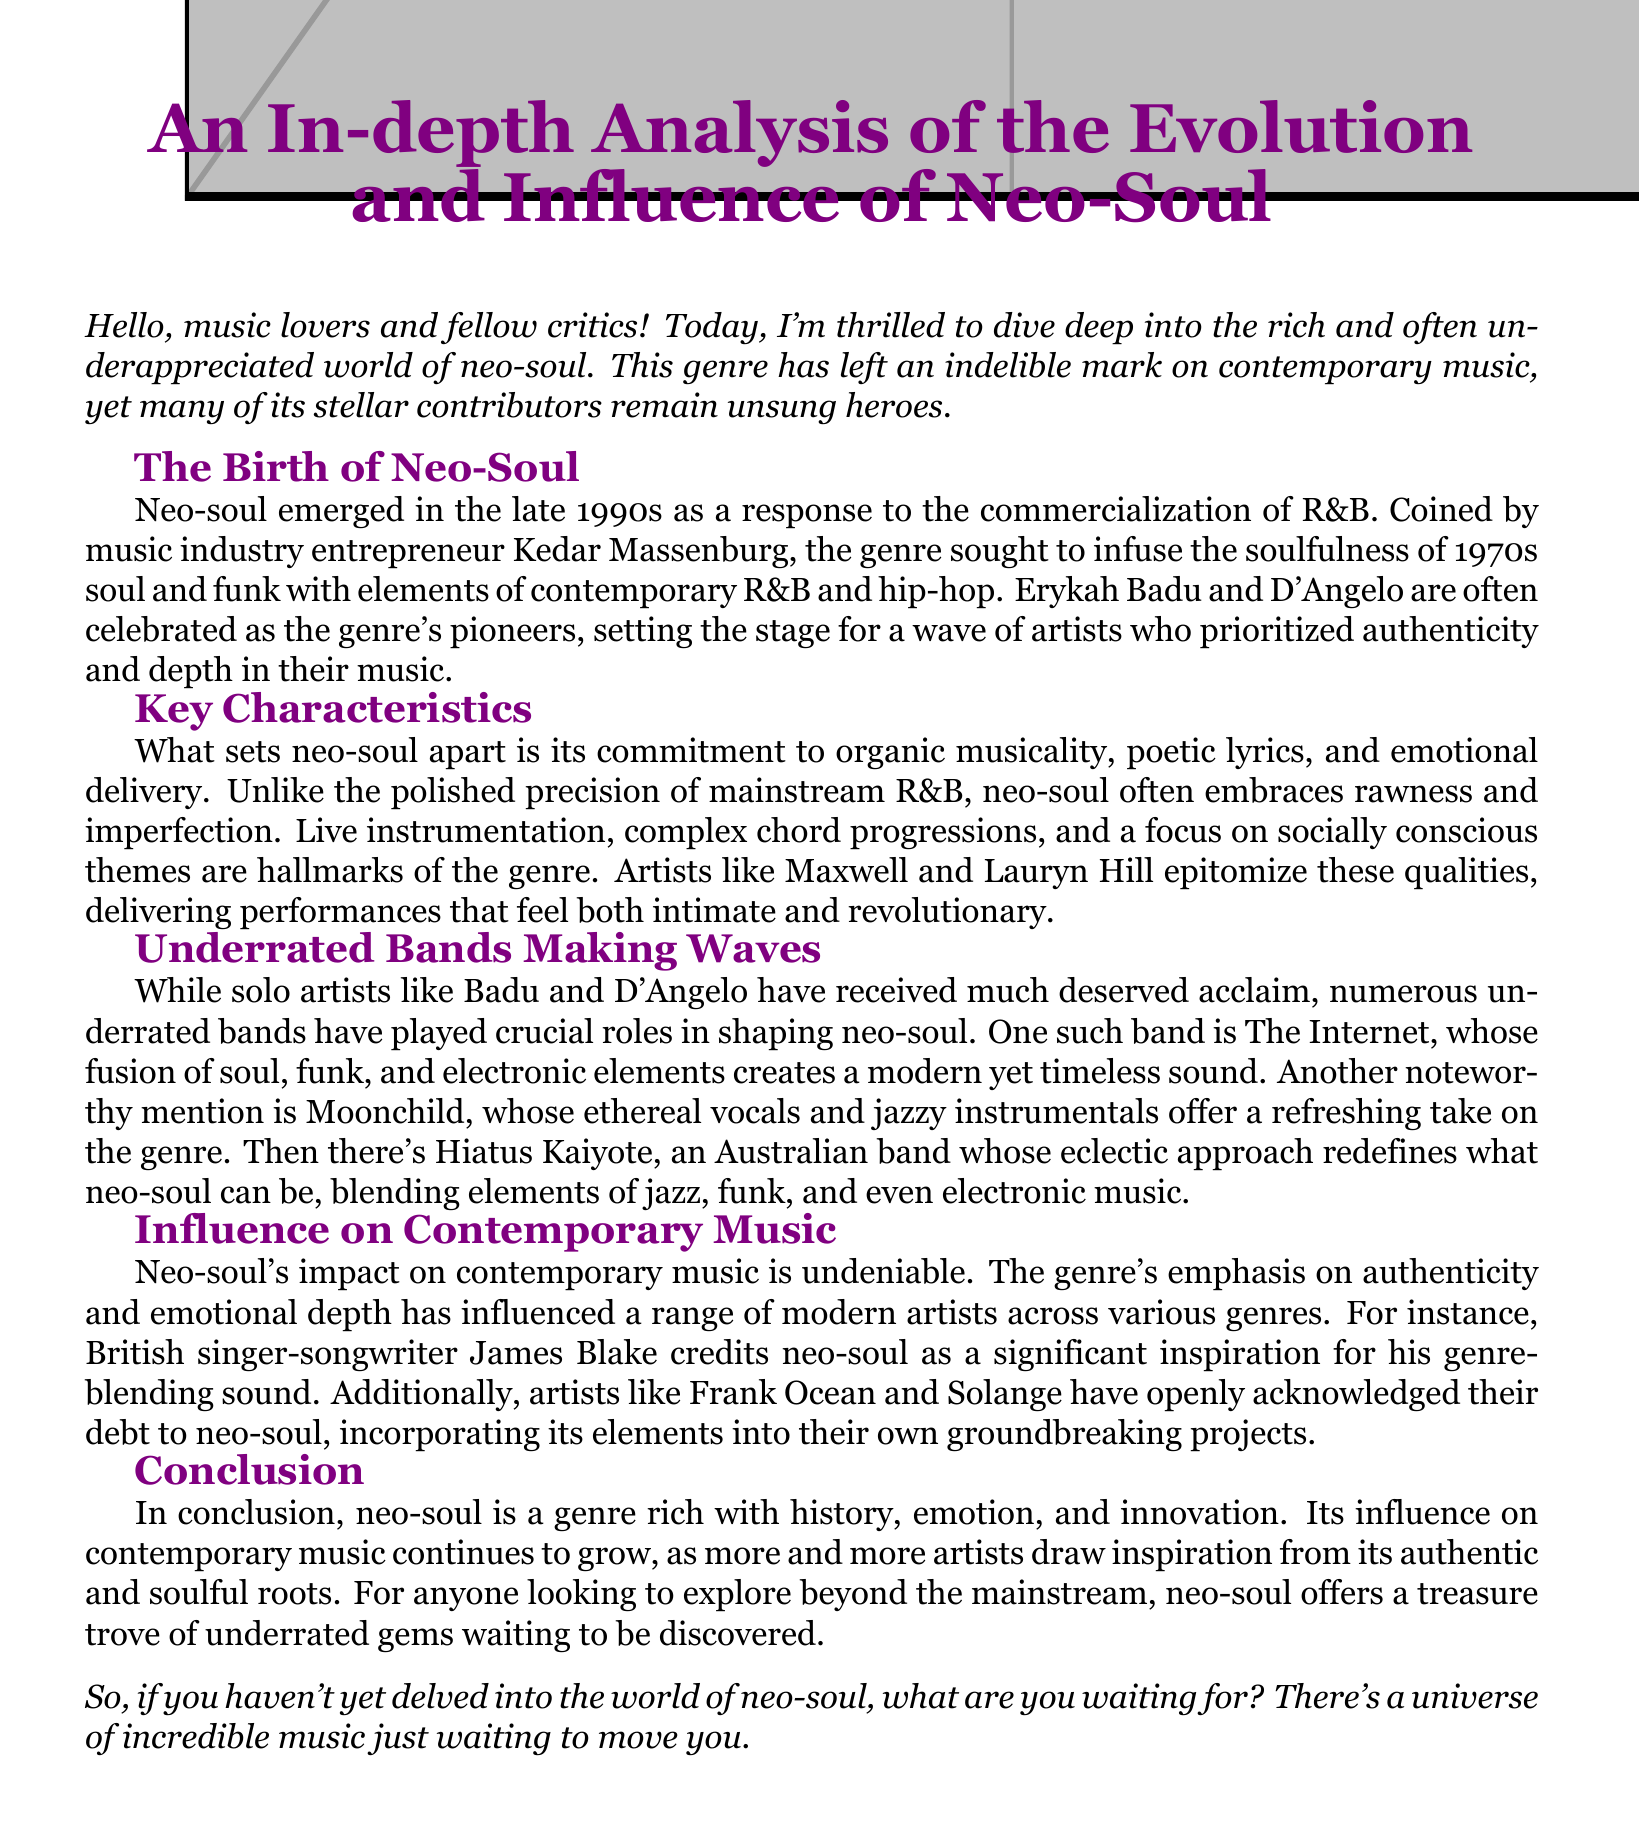What is the origin date of neo-soul? Neo-soul emerged in the late 1990s.
Answer: late 1990s Who coined the term 'neo-soul'? The term 'neo-soul' was coined by Kedar Massenburg.
Answer: Kedar Massenburg Which artists are considered pioneers of neo-soul? Erykah Badu and D'Angelo are often celebrated as the genre's pioneers.
Answer: Erykah Badu and D'Angelo Name one underrated band mentioned in the document. The document mentions The Internet, Moonchild, and Hiatus Kaiyote as underrated bands.
Answer: The Internet Which genre's elements did James Blake credit as an inspiration? James Blake credited neo-soul as a significant inspiration for his genre-blending sound.
Answer: neo-soul How do neo-soul bands typically deliver their music compared to mainstream R&B? Neo-soul often embraces rawness and imperfection, unlike the polished precision of mainstream R&B.
Answer: rawness and imperfection What characteristics set neo-soul apart from other genres? Neo-soul is characterized by organic musicality, poetic lyrics, and emotional delivery.
Answer: organic musicality, poetic lyrics, and emotional delivery How does the document describe neo-soul’s influence on contemporary music? The genre's emphasis on authenticity and emotional depth has influenced a range of modern artists.
Answer: authenticity and emotional depth What is the concluding call to action for readers in the document? The document encourages readers to explore the world of neo-soul for incredible music.
Answer: explore the world of neo-soul 